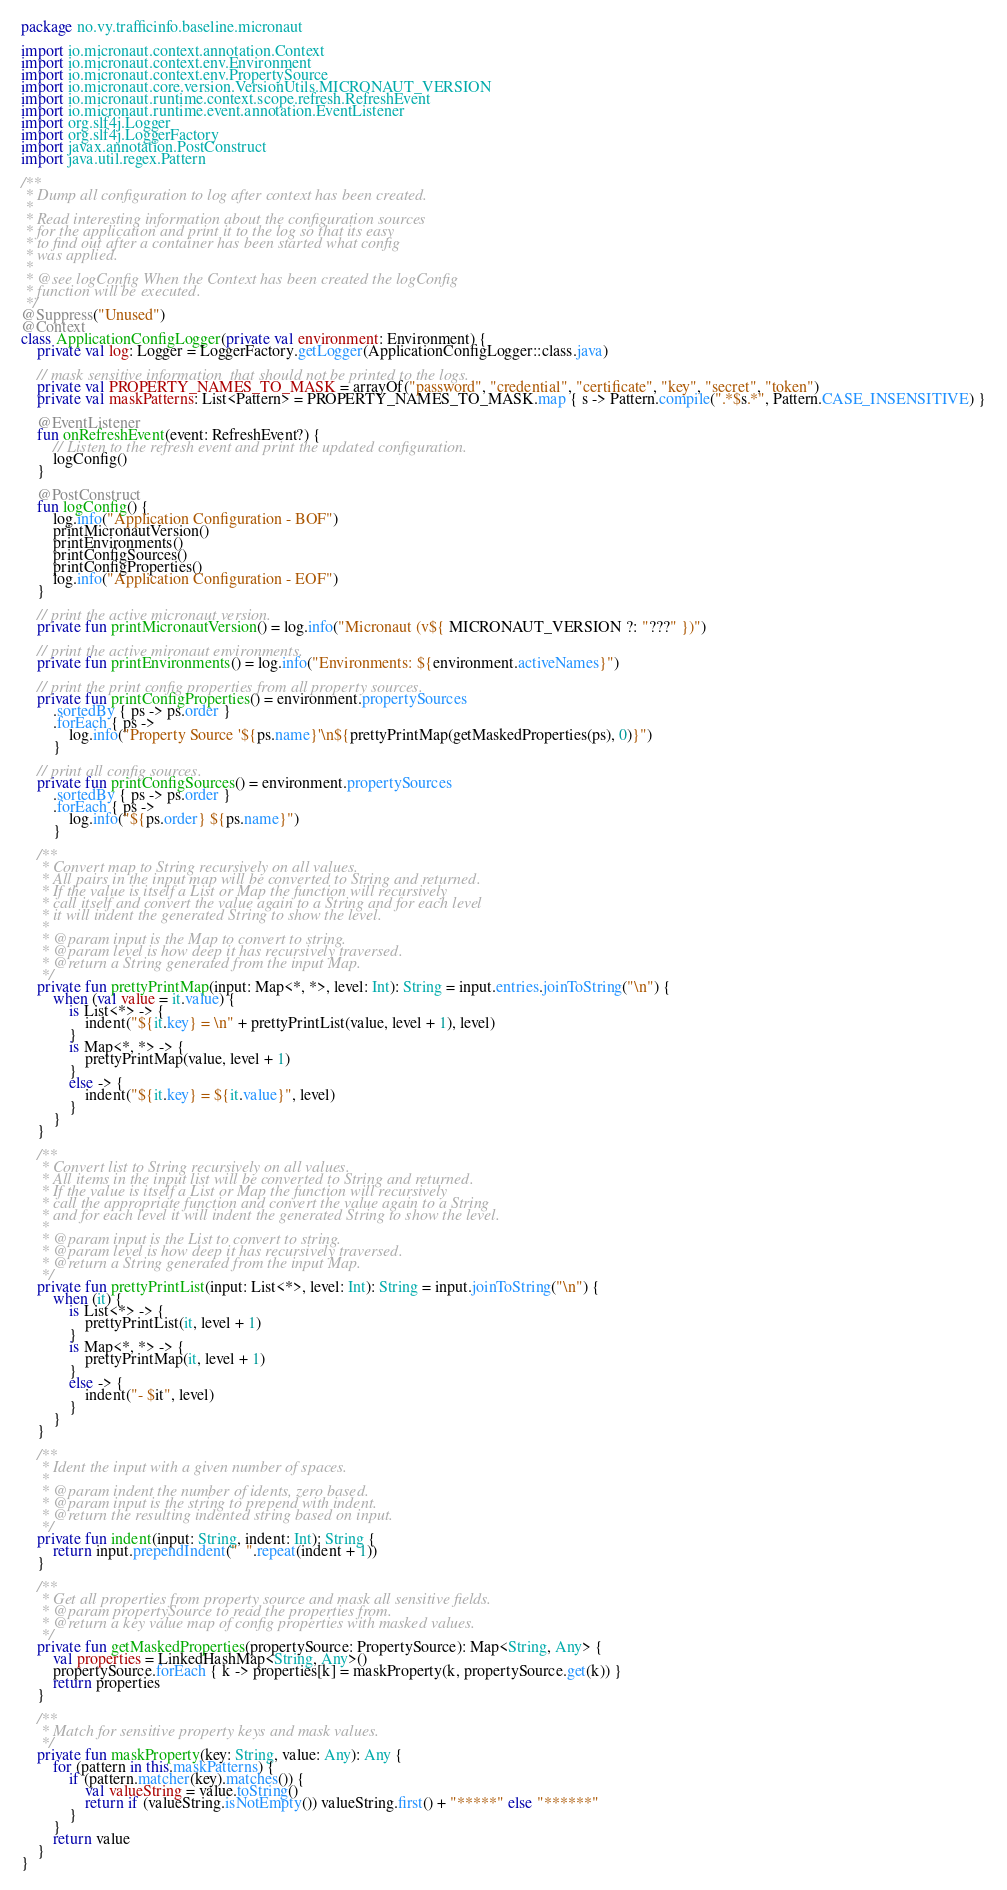Convert code to text. <code><loc_0><loc_0><loc_500><loc_500><_Kotlin_>package no.vy.trafficinfo.baseline.micronaut

import io.micronaut.context.annotation.Context
import io.micronaut.context.env.Environment
import io.micronaut.context.env.PropertySource
import io.micronaut.core.version.VersionUtils.MICRONAUT_VERSION
import io.micronaut.runtime.context.scope.refresh.RefreshEvent
import io.micronaut.runtime.event.annotation.EventListener
import org.slf4j.Logger
import org.slf4j.LoggerFactory
import javax.annotation.PostConstruct
import java.util.regex.Pattern

/**
 * Dump all configuration to log after context has been created.
 *
 * Read interesting information about the configuration sources
 * for the application and print it to the log so that its easy
 * to find out after a container has been started what config
 * was applied.
 *
 * @see logConfig When the Context has been created the logConfig
 * function will be executed.
 */
@Suppress("Unused")
@Context
class ApplicationConfigLogger(private val environment: Environment) {
    private val log: Logger = LoggerFactory.getLogger(ApplicationConfigLogger::class.java)

    // mask sensitive information  that should not be printed to the logs.
    private val PROPERTY_NAMES_TO_MASK = arrayOf("password", "credential", "certificate", "key", "secret", "token")
    private val maskPatterns: List<Pattern> = PROPERTY_NAMES_TO_MASK.map { s -> Pattern.compile(".*$s.*", Pattern.CASE_INSENSITIVE) }

    @EventListener
    fun onRefreshEvent(event: RefreshEvent?) {
        // Listen to the refresh event and print the updated configuration.
        logConfig()
    }

    @PostConstruct
    fun logConfig() {
        log.info("Application Configuration - BOF")
        printMicronautVersion()
        printEnvironments()
        printConfigSources()
        printConfigProperties()
        log.info("Application Configuration - EOF")
    }

    // print the active micronaut version.
    private fun printMicronautVersion() = log.info("Micronaut (v${ MICRONAUT_VERSION ?: "???" })")

    // print the active mironaut environments.
    private fun printEnvironments() = log.info("Environments: ${environment.activeNames}")

    // print the print config properties from all property sources.
    private fun printConfigProperties() = environment.propertySources
        .sortedBy { ps -> ps.order }
        .forEach { ps ->
            log.info("Property Source '${ps.name}'\n${prettyPrintMap(getMaskedProperties(ps), 0)}")
        }

    // print all config sources.
    private fun printConfigSources() = environment.propertySources
        .sortedBy { ps -> ps.order }
        .forEach { ps ->
            log.info("${ps.order} ${ps.name}")
        }

    /**
     * Convert map to String recursively on all values.
     * All pairs in the input map will be converted to String and returned.
     * If the value is itself a List or Map the function will recursively
     * call itself and convert the value again to a String and for each level
     * it will indent the generated String to show the level.
     *
     * @param input is the Map to convert to string.
     * @param level is how deep it has recursively traversed.
     * @return a String generated from the input Map.
     */
    private fun prettyPrintMap(input: Map<*, *>, level: Int): String = input.entries.joinToString("\n") {
        when (val value = it.value) {
            is List<*> -> {
                indent("${it.key} = \n" + prettyPrintList(value, level + 1), level)
            }
            is Map<*, *> -> {
                prettyPrintMap(value, level + 1)
            }
            else -> {
                indent("${it.key} = ${it.value}", level)
            }
        }
    }

    /**
     * Convert list to String recursively on all values.
     * All items in the input list will be converted to String and returned.
     * If the value is itself a List or Map the function will recursively
     * call the appropriate function and convert the value again to a String
     * and for each level it will indent the generated String to show the level.
     *
     * @param input is the List to convert to string.
     * @param level is how deep it has recursively traversed.
     * @return a String generated from the input Map.
     */
    private fun prettyPrintList(input: List<*>, level: Int): String = input.joinToString("\n") {
        when (it) {
            is List<*> -> {
                prettyPrintList(it, level + 1)
            }
            is Map<*, *> -> {
                prettyPrintMap(it, level + 1)
            }
            else -> {
                indent("- $it", level)
            }
        }
    }

    /**
     * Ident the input with a given number of spaces.
     *
     * @param indent the number of idents, zero based.
     * @param input is the string to prepend with indent.
     * @return the resulting indented string based on input.
     */
    private fun indent(input: String, indent: Int): String {
        return input.prependIndent("  ".repeat(indent + 1))
    }

    /**
     * Get all properties from property source and mask all sensitive fields.
     * @param propertySource to read the properties from.
     * @return a key value map of config properties with masked values.
     */
    private fun getMaskedProperties(propertySource: PropertySource): Map<String, Any> {
        val properties = LinkedHashMap<String, Any>()
        propertySource.forEach { k -> properties[k] = maskProperty(k, propertySource.get(k)) }
        return properties
    }

    /**
     * Match for sensitive property keys and mask values.
     */
    private fun maskProperty(key: String, value: Any): Any {
        for (pattern in this.maskPatterns) {
            if (pattern.matcher(key).matches()) {
                val valueString = value.toString()
                return if (valueString.isNotEmpty()) valueString.first() + "*****" else "******"
            }
        }
        return value
    }
}</code> 